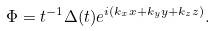<formula> <loc_0><loc_0><loc_500><loc_500>\Phi = t ^ { - 1 } \Delta ( t ) e ^ { i ( k _ { x } x + k _ { y } y + k _ { z } z ) } .</formula> 